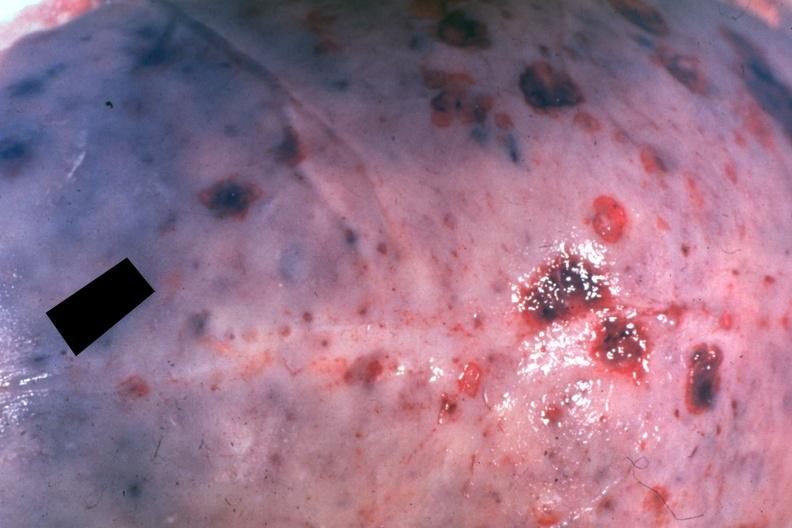what does this image show?
Answer the question using a single word or phrase. Dr garcia tumors b6 